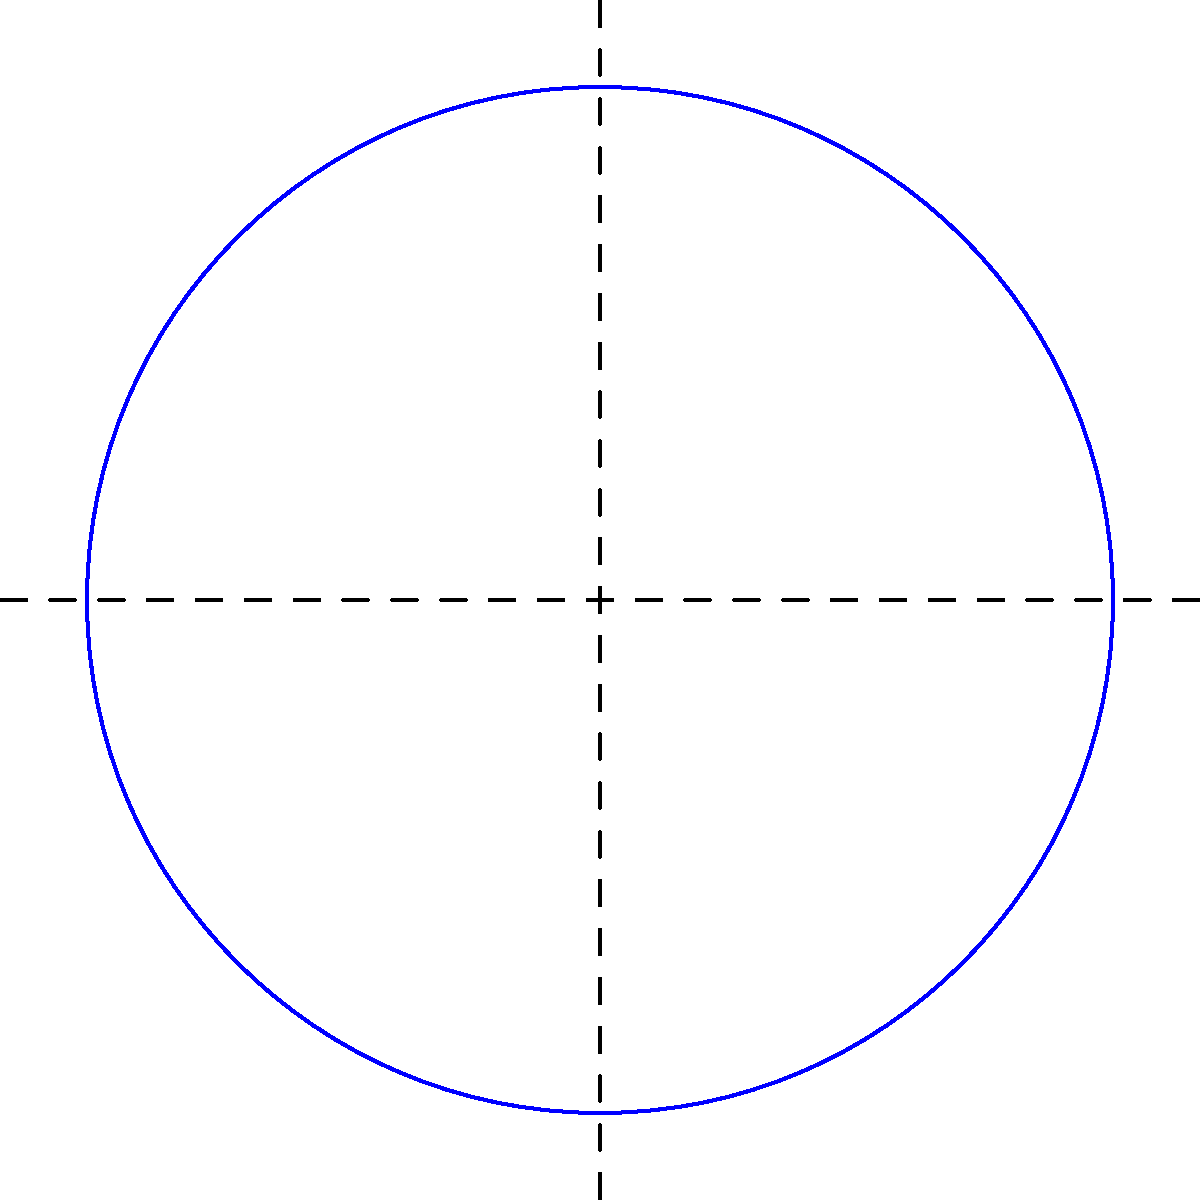As a car magazine editor, you're writing a feature on a billionaire's circular driveway designed to showcase their collector cars. The driveway needs to accommodate 8 cars, each with dimensions of 1.2m by 0.6m, arranged around the circle's circumference. If the cars are placed with their long sides tangent to the circle and a 0.3m gap between each car, what is the minimum radius of the circular driveway needed? Round your answer to the nearest tenth of a meter. Let's approach this step-by-step:

1) First, we need to calculate the arc length each car occupies on the circumference:
   - Car width = 0.6m
   - Gap between cars = 0.3m
   - Total arc length per car = 0.6m + 0.3m = 0.9m

2) Now, we can calculate the total arc length needed for all 8 cars:
   $8 \times 0.9m = 7.2m$

3) This total arc length equals the circumference of the circle. We can use the formula for circumference to find the radius:
   $C = 2\pi r$, where $C$ is circumference and $r$ is radius

4) Substituting our known circumference:
   $7.2 = 2\pi r$

5) Solving for $r$:
   $r = \frac{7.2}{2\pi} \approx 1.146m$

6) However, this is the radius to the inner edge of the cars. We need to add half the car's length to get the true radius of the driveway:
   $1.146m + (1.2m / 2) = 1.146m + 0.6m = 1.746m$

7) Rounding to the nearest tenth:
   $1.746m \approx 1.7m$

Therefore, the minimum radius of the circular driveway needed is approximately 1.7 meters.
Answer: 1.7 meters 